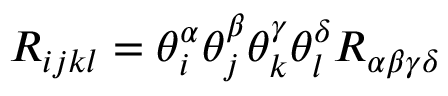<formula> <loc_0><loc_0><loc_500><loc_500>R _ { i j k l } = \theta _ { i } ^ { \alpha } \theta _ { j } ^ { \beta } \theta _ { k } ^ { \gamma } \theta _ { l } ^ { \delta } R _ { \alpha \beta \gamma \delta }</formula> 